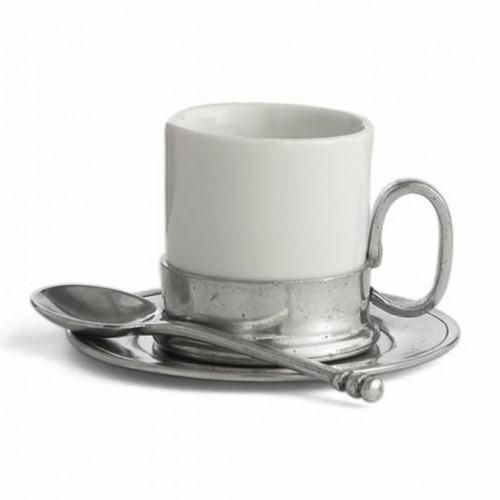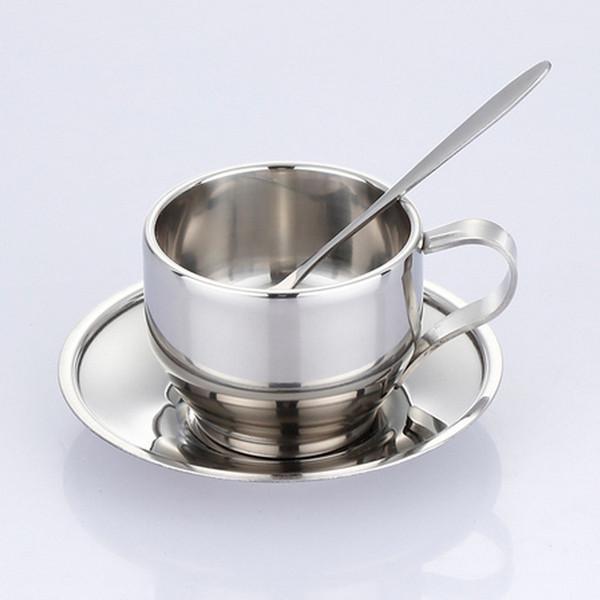The first image is the image on the left, the second image is the image on the right. Considering the images on both sides, is "The spoon is in the cup in the image on the right." valid? Answer yes or no. Yes. 